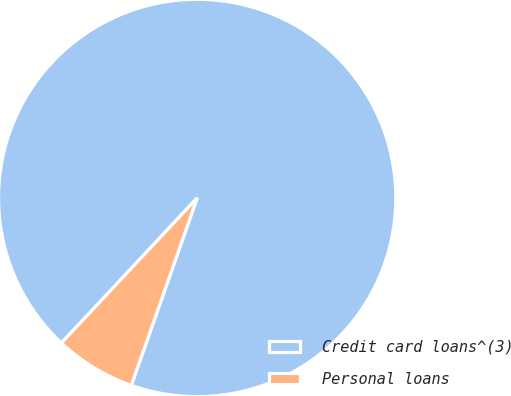<chart> <loc_0><loc_0><loc_500><loc_500><pie_chart><fcel>Credit card loans^(3)<fcel>Personal loans<nl><fcel>93.41%<fcel>6.59%<nl></chart> 